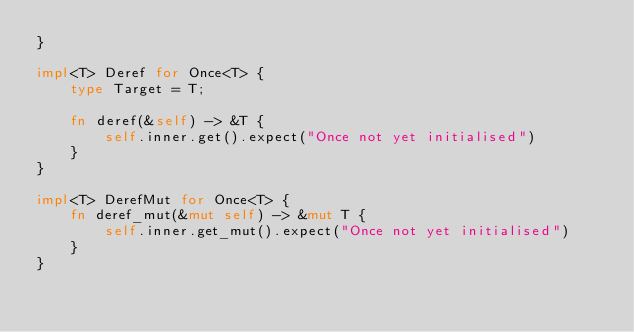<code> <loc_0><loc_0><loc_500><loc_500><_Rust_>}

impl<T> Deref for Once<T> {
    type Target = T;

    fn deref(&self) -> &T {
        self.inner.get().expect("Once not yet initialised")
    }
}

impl<T> DerefMut for Once<T> {
    fn deref_mut(&mut self) -> &mut T {
        self.inner.get_mut().expect("Once not yet initialised")
    }
}</code> 